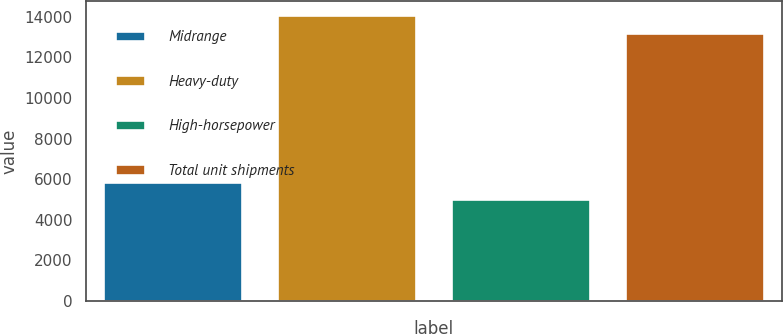Convert chart. <chart><loc_0><loc_0><loc_500><loc_500><bar_chart><fcel>Midrange<fcel>Heavy-duty<fcel>High-horsepower<fcel>Total unit shipments<nl><fcel>5870<fcel>14070<fcel>5000<fcel>13200<nl></chart> 